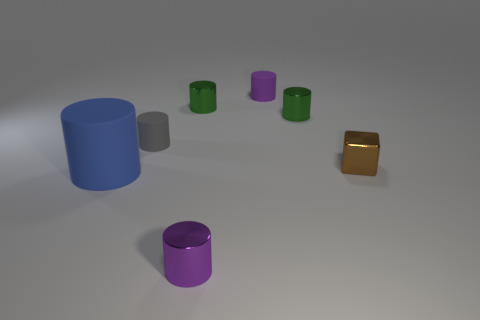Add 2 shiny cubes. How many objects exist? 9 Subtract all tiny purple cylinders. How many cylinders are left? 4 Subtract all green blocks. How many purple cylinders are left? 2 Subtract all green cylinders. How many cylinders are left? 4 Subtract 2 cylinders. How many cylinders are left? 4 Subtract 1 brown cubes. How many objects are left? 6 Subtract all cubes. How many objects are left? 6 Subtract all blue cylinders. Subtract all red spheres. How many cylinders are left? 5 Subtract all large blue matte objects. Subtract all metallic blocks. How many objects are left? 5 Add 7 large blue objects. How many large blue objects are left? 8 